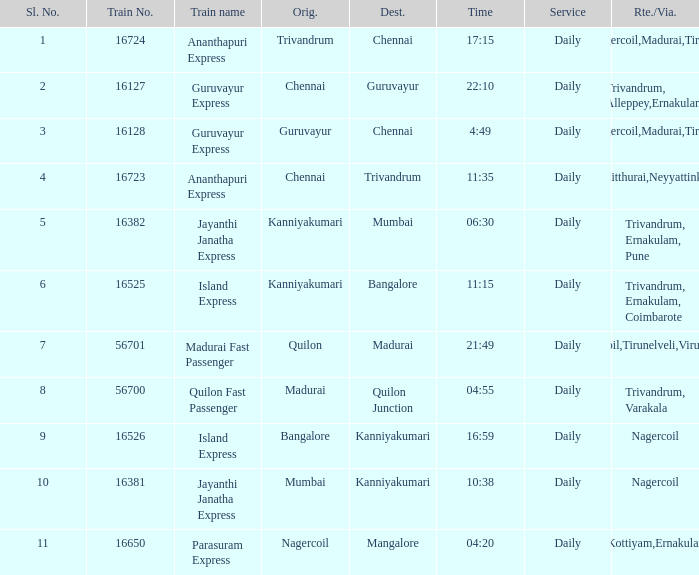What is the train number when the time is 10:38? 16381.0. 